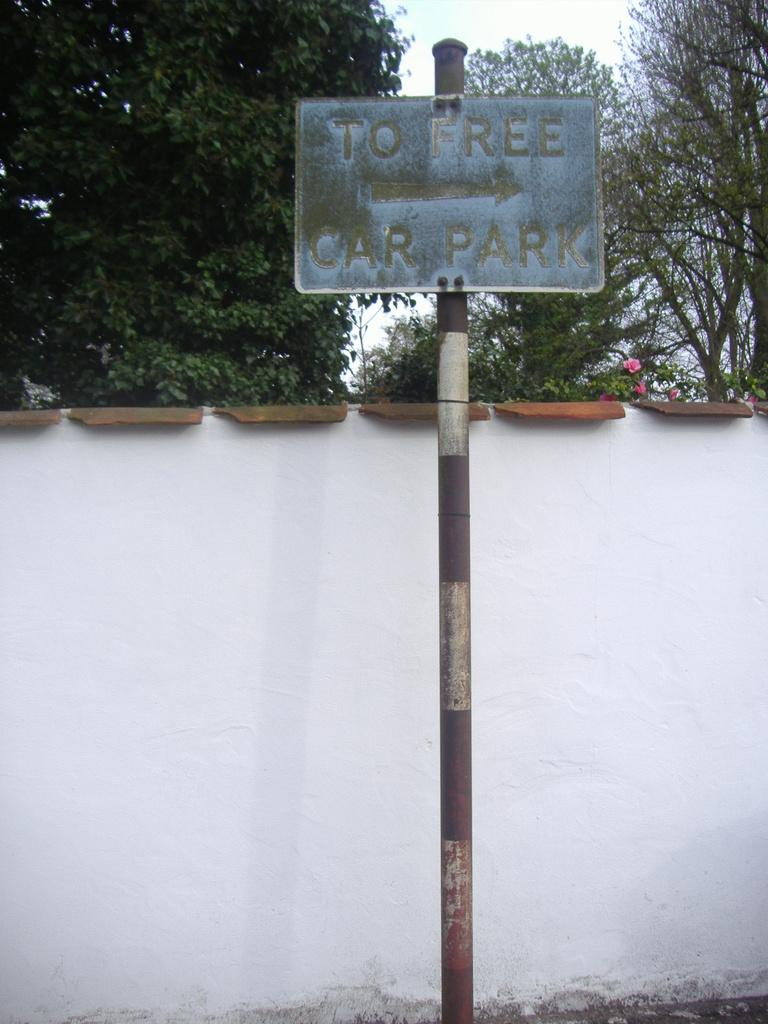What is the main object at the center of the image? There is a sign board at the center of the image. What is located behind the sign board? There is a wall on the backside of the image. What can be seen in the background of the image? There are trees and the sky visible in the background of the image. How much debt is represented by the sign board in the image? There is no indication of debt or financial information on the sign board in the image. Can you see a swing in the image? There is no swing present in the image. 